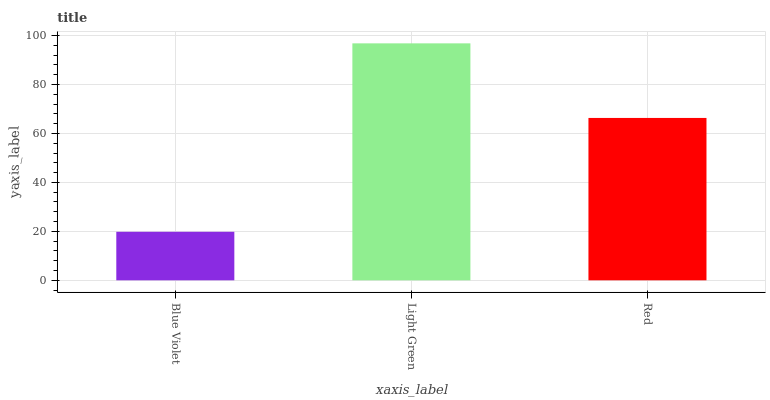Is Blue Violet the minimum?
Answer yes or no. Yes. Is Light Green the maximum?
Answer yes or no. Yes. Is Red the minimum?
Answer yes or no. No. Is Red the maximum?
Answer yes or no. No. Is Light Green greater than Red?
Answer yes or no. Yes. Is Red less than Light Green?
Answer yes or no. Yes. Is Red greater than Light Green?
Answer yes or no. No. Is Light Green less than Red?
Answer yes or no. No. Is Red the high median?
Answer yes or no. Yes. Is Red the low median?
Answer yes or no. Yes. Is Blue Violet the high median?
Answer yes or no. No. Is Light Green the low median?
Answer yes or no. No. 